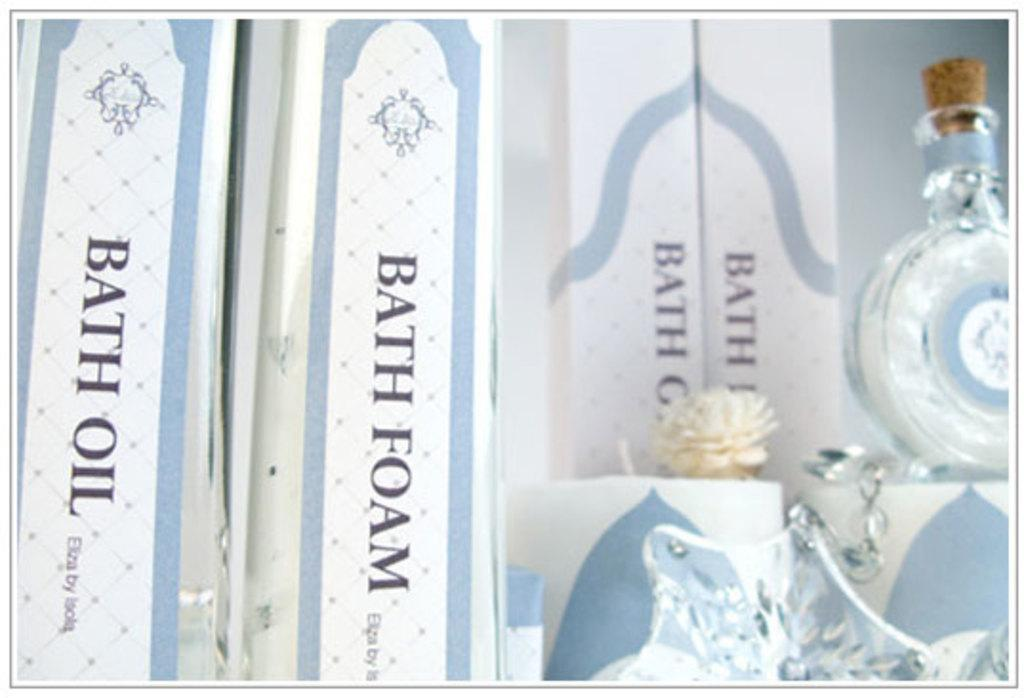Provide a one-sentence caption for the provided image. Bath foam and bath oil with perfume also. 